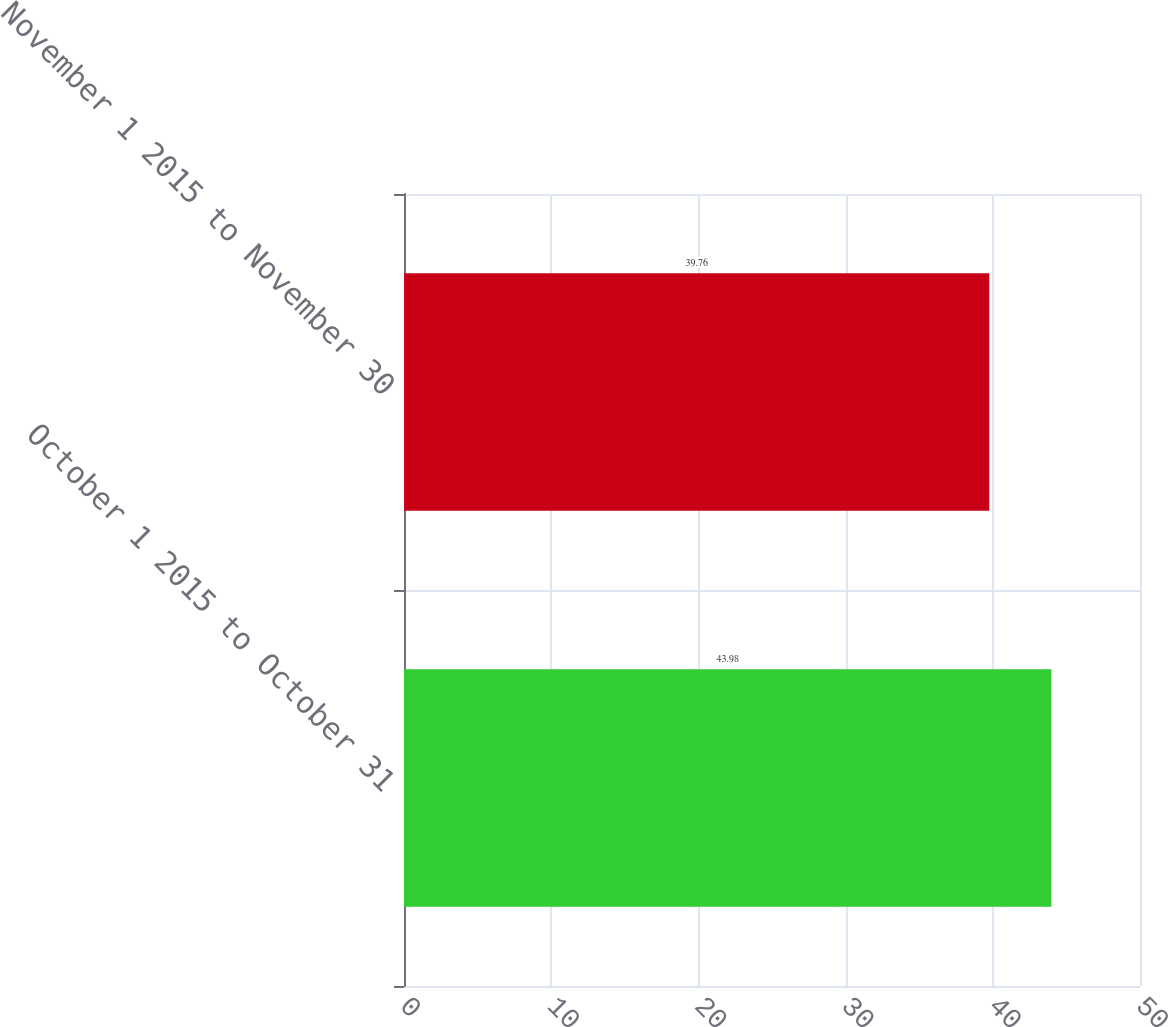Convert chart. <chart><loc_0><loc_0><loc_500><loc_500><bar_chart><fcel>October 1 2015 to October 31<fcel>November 1 2015 to November 30<nl><fcel>43.98<fcel>39.76<nl></chart> 